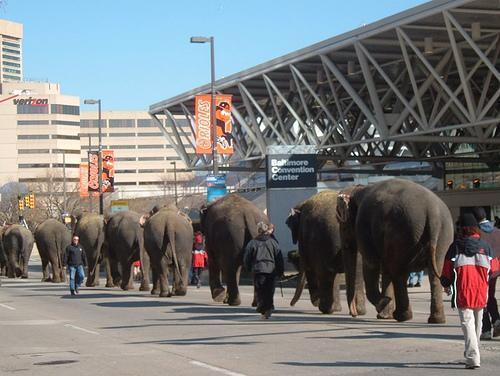How many elephants are shown?
Give a very brief answer. 8. 